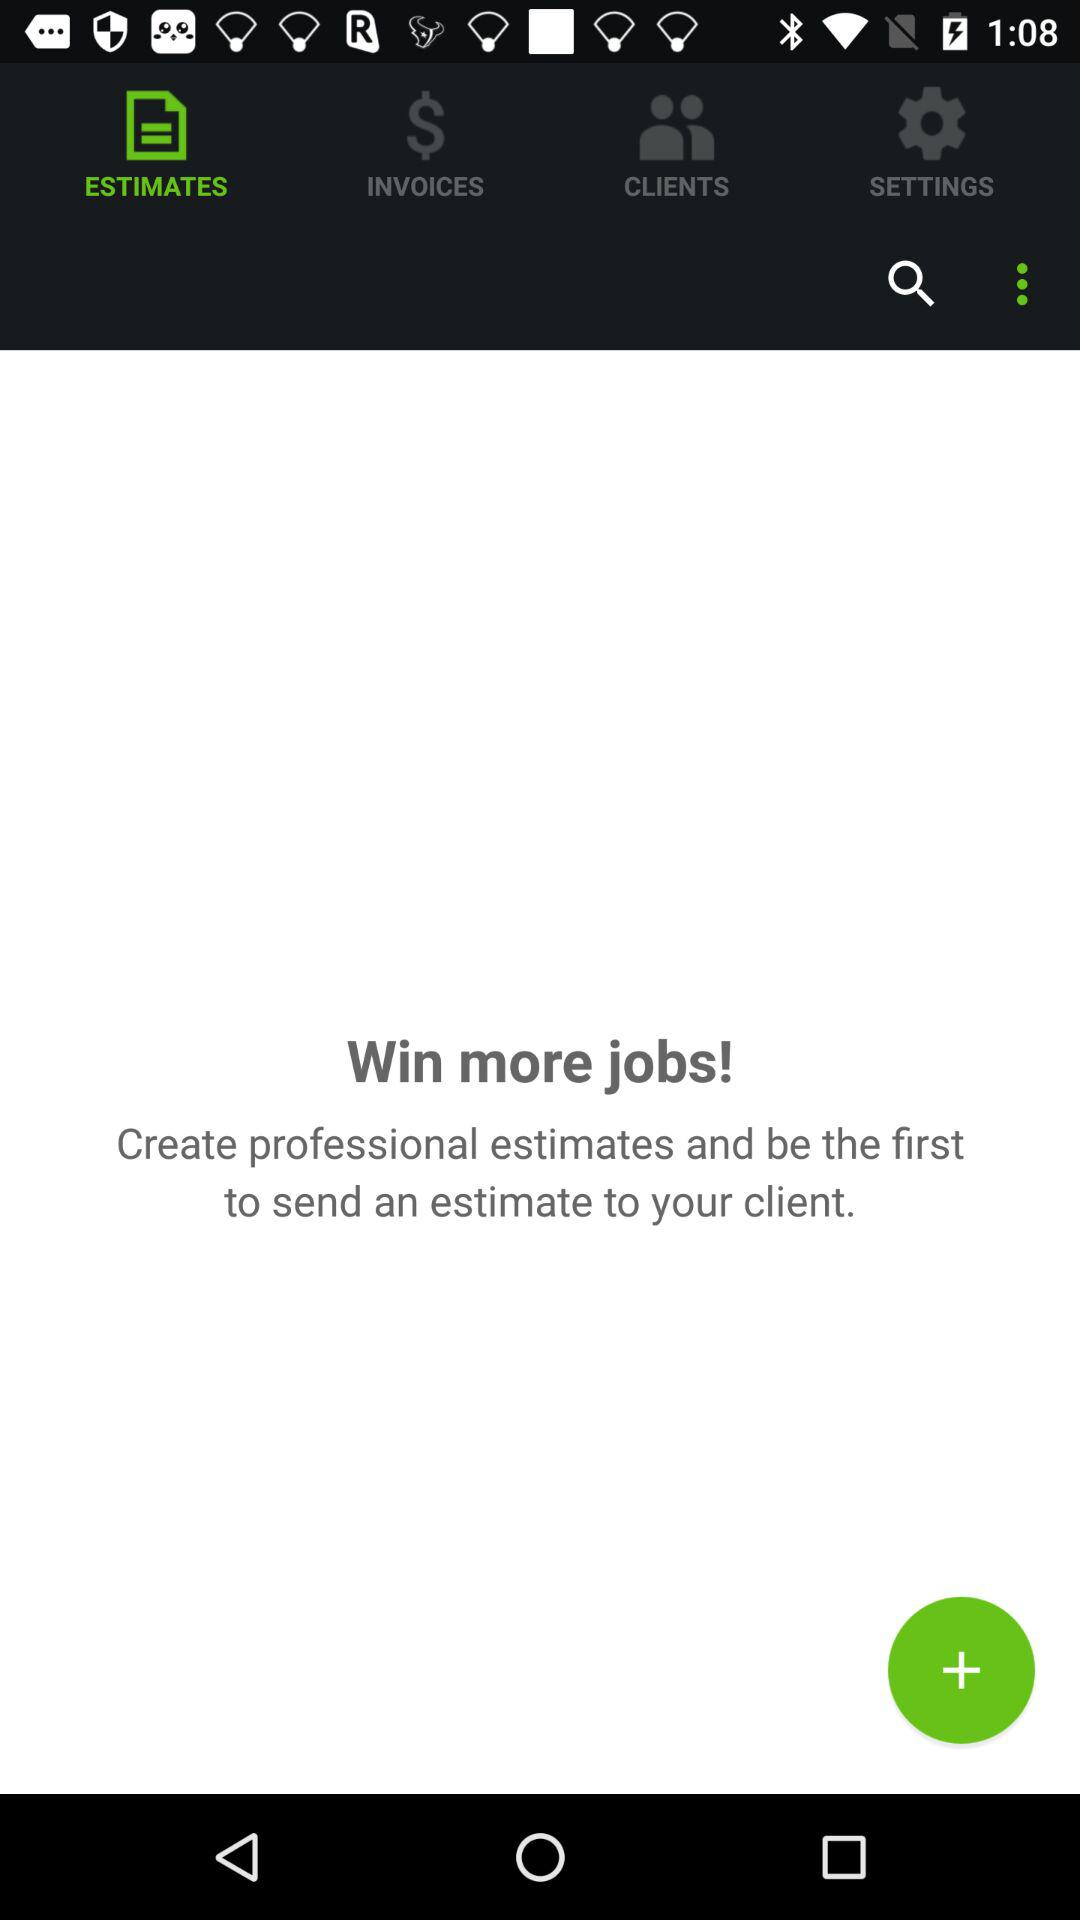What tab am I on? You are on the "ESTIMATES" tab. 